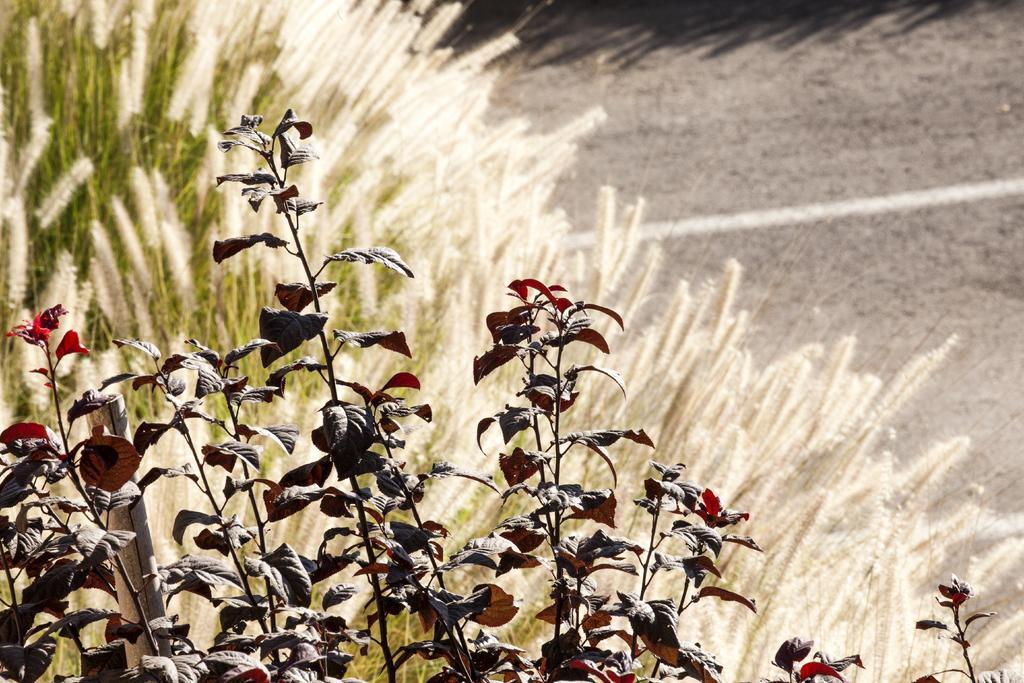Could you give a brief overview of what you see in this image? In this picture we can see leaves, wooden stick, plants and in the background we can see the road. 